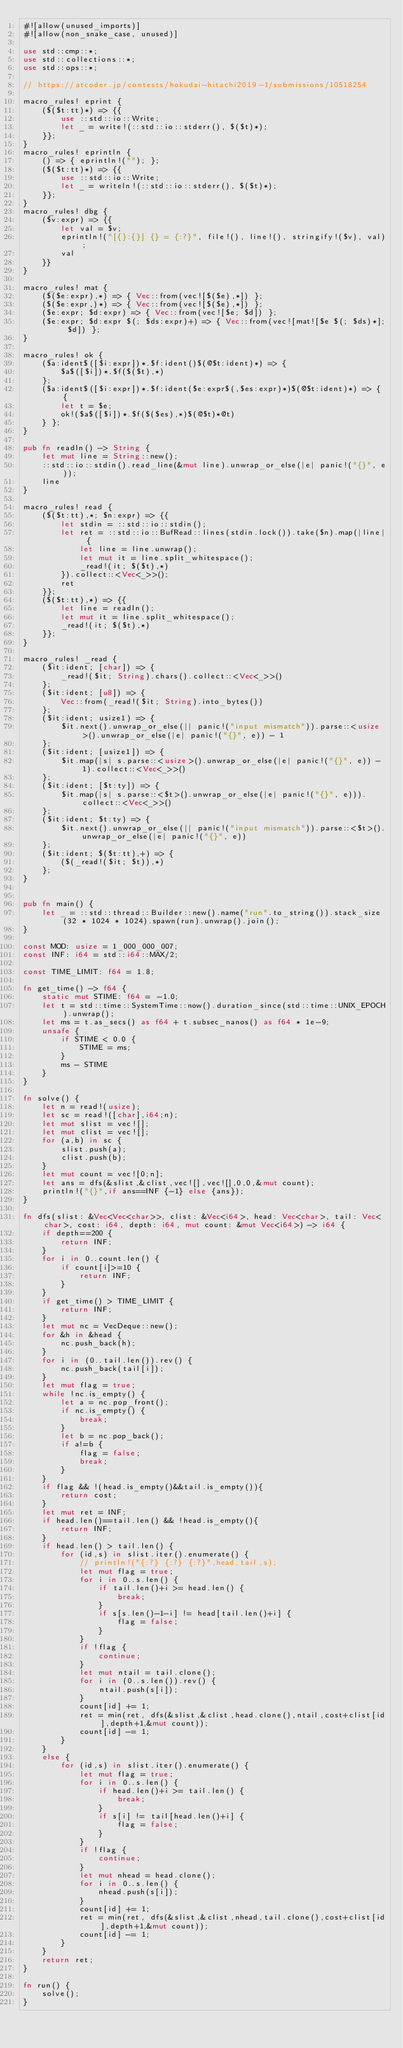Convert code to text. <code><loc_0><loc_0><loc_500><loc_500><_Rust_>#![allow(unused_imports)]
#![allow(non_snake_case, unused)]

use std::cmp::*;
use std::collections::*;
use std::ops::*;

// https://atcoder.jp/contests/hokudai-hitachi2019-1/submissions/10518254

macro_rules! eprint {
    ($($t:tt)*) => {{
        use ::std::io::Write;
        let _ = write!(::std::io::stderr(), $($t)*);
    }};
}
macro_rules! eprintln {
    () => { eprintln!(""); };
    ($($t:tt)*) => {{
        use ::std::io::Write;
        let _ = writeln!(::std::io::stderr(), $($t)*);
    }};
}
macro_rules! dbg {
    ($v:expr) => {{
        let val = $v;
        eprintln!("[{}:{}] {} = {:?}", file!(), line!(), stringify!($v), val);
        val
    }}
}

macro_rules! mat {
    ($($e:expr),*) => { Vec::from(vec![$($e),*]) };
    ($($e:expr,)*) => { Vec::from(vec![$($e),*]) };
    ($e:expr; $d:expr) => { Vec::from(vec![$e; $d]) };
    ($e:expr; $d:expr $(; $ds:expr)+) => { Vec::from(vec![mat![$e $(; $ds)*]; $d]) };
}

macro_rules! ok {
    ($a:ident$([$i:expr])*.$f:ident()$(@$t:ident)*) => {
        $a$([$i])*.$f($($t),*)
    };
    ($a:ident$([$i:expr])*.$f:ident($e:expr$(,$es:expr)*)$(@$t:ident)*) => { {
        let t = $e;
        ok!($a$([$i])*.$f($($es),*)$(@$t)*@t)
    } };
}

pub fn readln() -> String {
    let mut line = String::new();
    ::std::io::stdin().read_line(&mut line).unwrap_or_else(|e| panic!("{}", e));
    line
}

macro_rules! read {
    ($($t:tt),*; $n:expr) => {{
        let stdin = ::std::io::stdin();
        let ret = ::std::io::BufRead::lines(stdin.lock()).take($n).map(|line| {
            let line = line.unwrap();
            let mut it = line.split_whitespace();
            _read!(it; $($t),*)
        }).collect::<Vec<_>>();
        ret
    }};
    ($($t:tt),*) => {{
        let line = readln();
        let mut it = line.split_whitespace();
        _read!(it; $($t),*)
    }};
}

macro_rules! _read {
    ($it:ident; [char]) => {
        _read!($it; String).chars().collect::<Vec<_>>()
    };
    ($it:ident; [u8]) => {
        Vec::from(_read!($it; String).into_bytes())
    };
    ($it:ident; usize1) => {
        $it.next().unwrap_or_else(|| panic!("input mismatch")).parse::<usize>().unwrap_or_else(|e| panic!("{}", e)) - 1
    };
    ($it:ident; [usize1]) => {
        $it.map(|s| s.parse::<usize>().unwrap_or_else(|e| panic!("{}", e)) - 1).collect::<Vec<_>>()
    };
    ($it:ident; [$t:ty]) => {
        $it.map(|s| s.parse::<$t>().unwrap_or_else(|e| panic!("{}", e))).collect::<Vec<_>>()
    };
    ($it:ident; $t:ty) => {
        $it.next().unwrap_or_else(|| panic!("input mismatch")).parse::<$t>().unwrap_or_else(|e| panic!("{}", e))
    };
    ($it:ident; $($t:tt),+) => {
        ($(_read!($it; $t)),*)
    };
}


pub fn main() {
    let _ = ::std::thread::Builder::new().name("run".to_string()).stack_size(32 * 1024 * 1024).spawn(run).unwrap().join();
}

const MOD: usize = 1_000_000_007;
const INF: i64 = std::i64::MAX/2;

const TIME_LIMIT: f64 = 1.8;
 
fn get_time() -> f64 {
	static mut STIME: f64 = -1.0;
	let t = std::time::SystemTime::now().duration_since(std::time::UNIX_EPOCH).unwrap();
	let ms = t.as_secs() as f64 + t.subsec_nanos() as f64 * 1e-9;
	unsafe {
		if STIME < 0.0 {
			STIME = ms;
		}
		ms - STIME
	}
}

fn solve() {
    let n = read!(usize);
    let sc = read!([char],i64;n);
    let mut slist = vec![];
    let mut clist = vec![];
    for (a,b) in sc {
        slist.push(a);
        clist.push(b);
    }
    let mut count = vec![0;n];
    let ans = dfs(&slist,&clist,vec![],vec![],0,0,&mut count);
    println!("{}",if ans==INF {-1} else {ans});
}

fn dfs(slist: &Vec<Vec<char>>, clist: &Vec<i64>, head: Vec<char>, tail: Vec<char>, cost: i64, depth: i64, mut count: &mut Vec<i64>) -> i64 {
    if depth==200 {
        return INF;
    }
    for i in 0..count.len() {
        if count[i]>=10 {
            return INF;
        }
    }
    if get_time() > TIME_LIMIT {
        return INF;
    }
    let mut nc = VecDeque::new();
    for &h in &head {
        nc.push_back(h);
    }
    for i in (0..tail.len()).rev() {
        nc.push_back(tail[i]);
    }
    let mut flag = true;
    while !nc.is_empty() {
        let a = nc.pop_front();
        if nc.is_empty() {
            break;
        }
        let b = nc.pop_back();
        if a!=b {
            flag = false;
            break;
        }
    }
    if flag && !(head.is_empty()&&tail.is_empty()){
        return cost;
    }
    let mut ret = INF;
    if head.len()==tail.len() && !head.is_empty(){
        return INF;
    }
    if head.len() > tail.len() {
        for (id,s) in slist.iter().enumerate() {
            // println!("{:?} {:?} {:?}",head,tail,s);
            let mut flag = true;
            for i in 0..s.len() {
                if tail.len()+i >= head.len() {
                    break;
                }
                if s[s.len()-1-i] != head[tail.len()+i] {
                    flag = false;
                }
            }
            if !flag {
                continue;
            }
            let mut ntail = tail.clone();
            for i in (0..s.len()).rev() {
                ntail.push(s[i]);
            }
            count[id] += 1;
            ret = min(ret, dfs(&slist,&clist,head.clone(),ntail,cost+clist[id],depth+1,&mut count));
            count[id] -= 1;
        }
    }
    else {
        for (id,s) in slist.iter().enumerate() {
            let mut flag = true;
            for i in 0..s.len() {
                if head.len()+i >= tail.len() {
                    break;
                }
                if s[i] != tail[head.len()+i] {
                    flag = false;
                }
            }
            if !flag {
                continue;
            }
            let mut nhead = head.clone();
            for i in 0..s.len() {
                nhead.push(s[i]);
            }
            count[id] += 1;
            ret = min(ret, dfs(&slist,&clist,nhead,tail.clone(),cost+clist[id],depth+1,&mut count));
            count[id] -= 1;
        }
    }
    return ret;
}

fn run() {
    solve();
}
</code> 